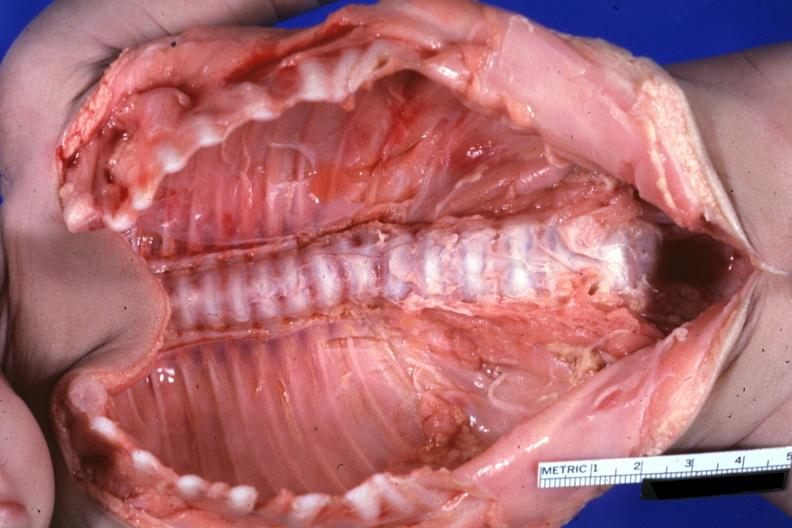what is present?
Answer the question using a single word or phrase. Joints 